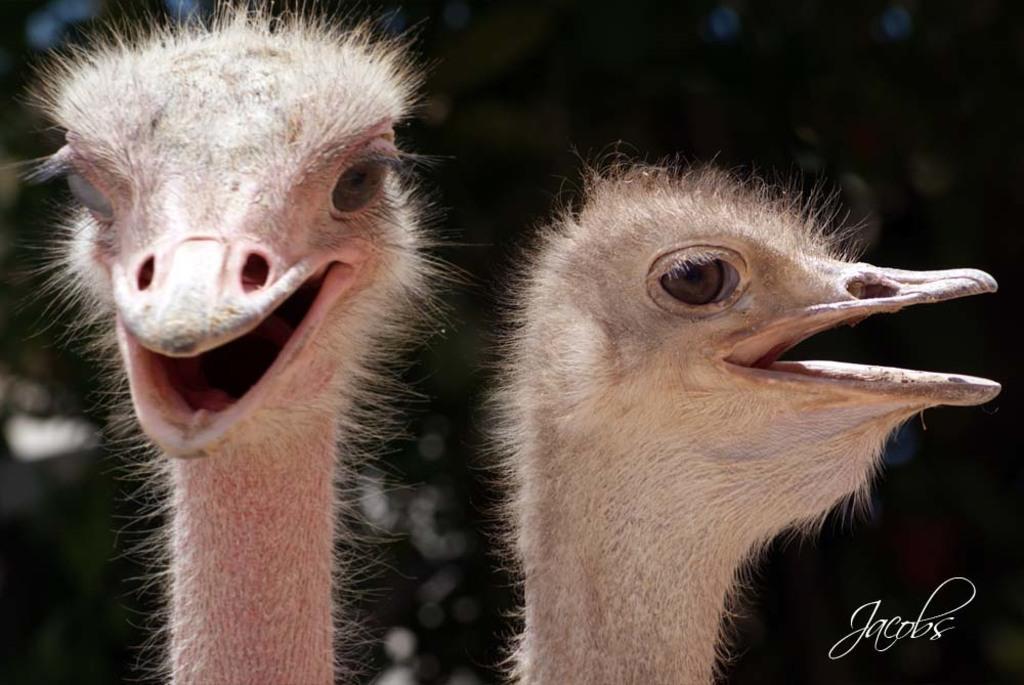In one or two sentences, can you explain what this image depicts? In this image I can see two ostrich. In the background it is blur. At the bottom right side of the image there is a watermark. 